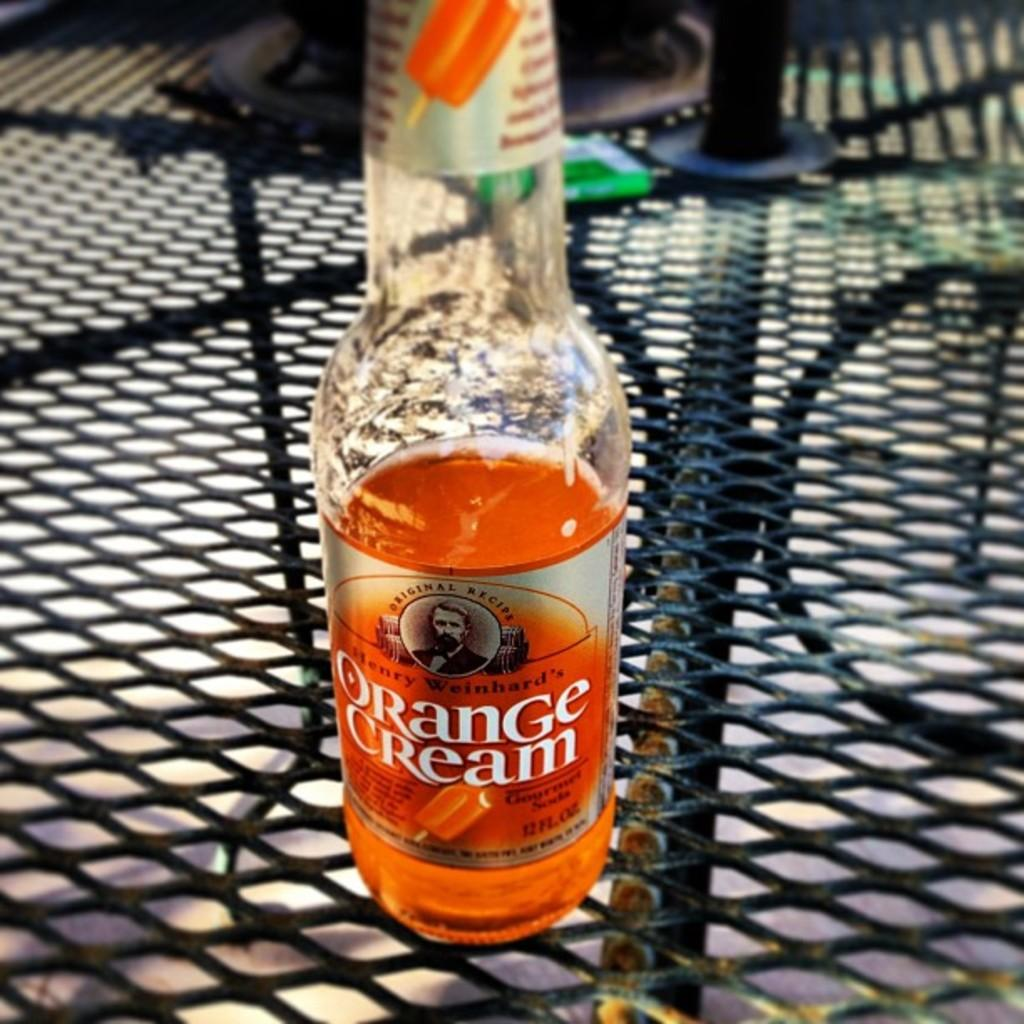<image>
Relay a brief, clear account of the picture shown. A half full bottle of orange cream soda sits on a table. 